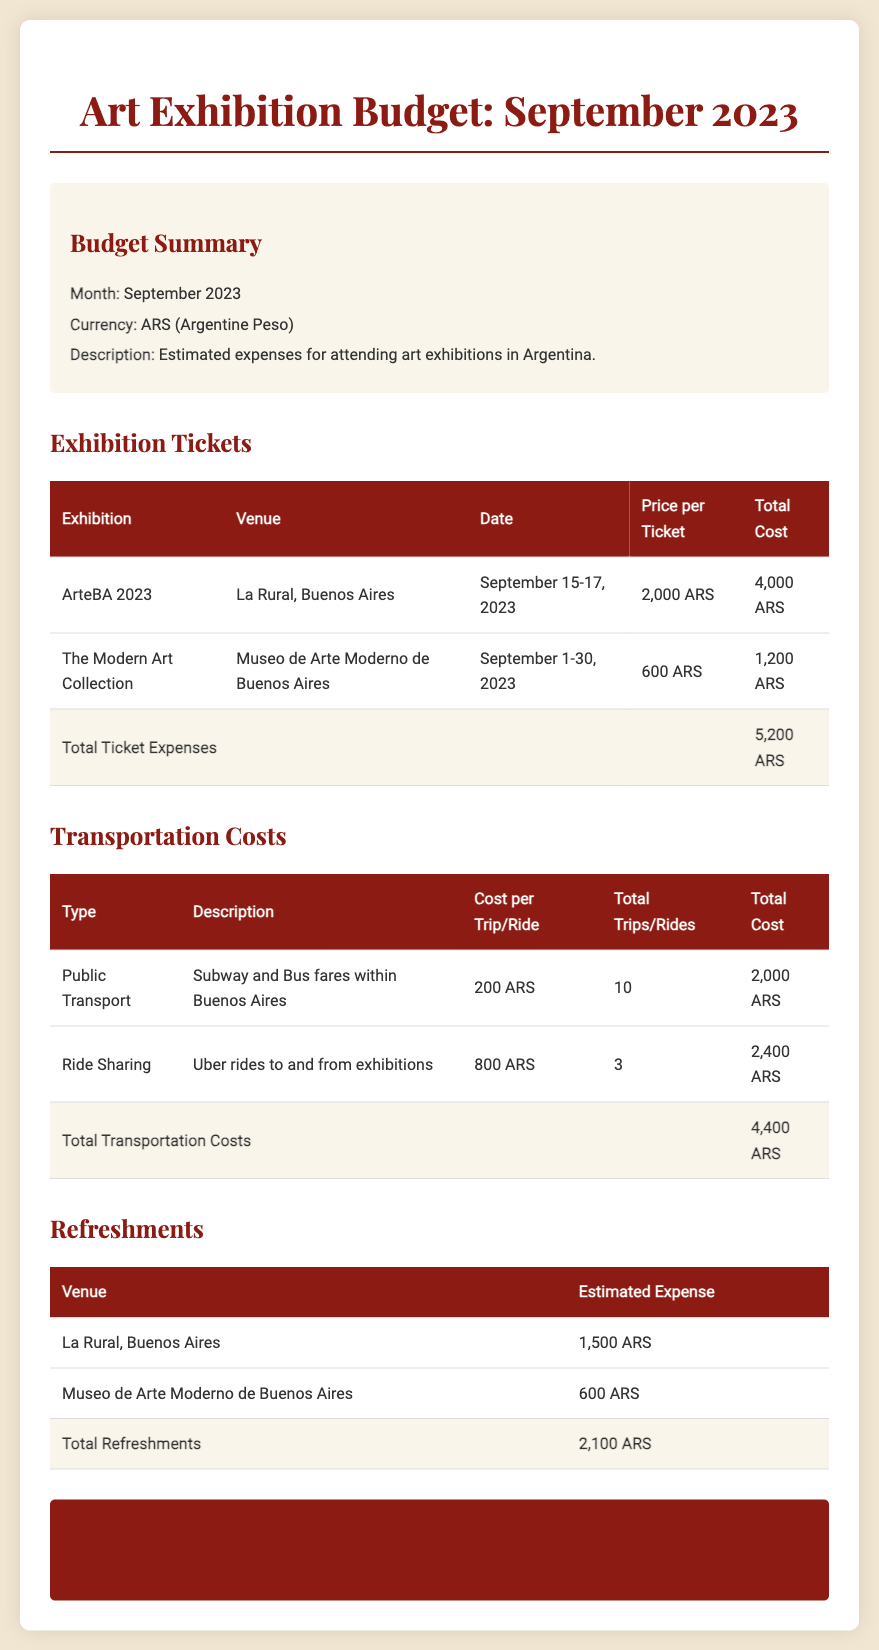What is the total cost of exhibition tickets? The total cost of exhibition tickets is found at the bottom of the ticket expenses table, which sums the individual ticket costs.
Answer: 5,200 ARS How much is the ticket for ArteBA 2023? The ticket price for ArteBA 2023 is listed in the exhibition tickets section under "Price per Ticket."
Answer: 2,000 ARS What is the total cost for refreshments? The total cost for refreshments is presented in the refreshments table, totaling the estimated expenses across venues.
Answer: 2,100 ARS How many public transport trips are included in the budget? The total trips for public transport are specified in the transportation costs section under "Total Trips/Rides."
Answer: 10 What is the overall total budget for September 2023? The overall total budget is clearly stated at the bottom of the document, summarizing all expenses.
Answer: 11,700 ARS How many Uber rides are budgeted for? The number of Uber rides is indicated in the transportation costs section under "Total Trips/Rides" for Ride Sharing.
Answer: 3 What is the venue for The Modern Art Collection? The venue for The Modern Art Collection is provided in the exhibition tickets section alongside the exhibition title.
Answer: Museo de Arte Moderno de Buenos Aires What is the cost per trip for ride sharing? The cost per trip for ride sharing is displayed in the transportation costs table under "Cost per Trip/Ride."
Answer: 800 ARS 